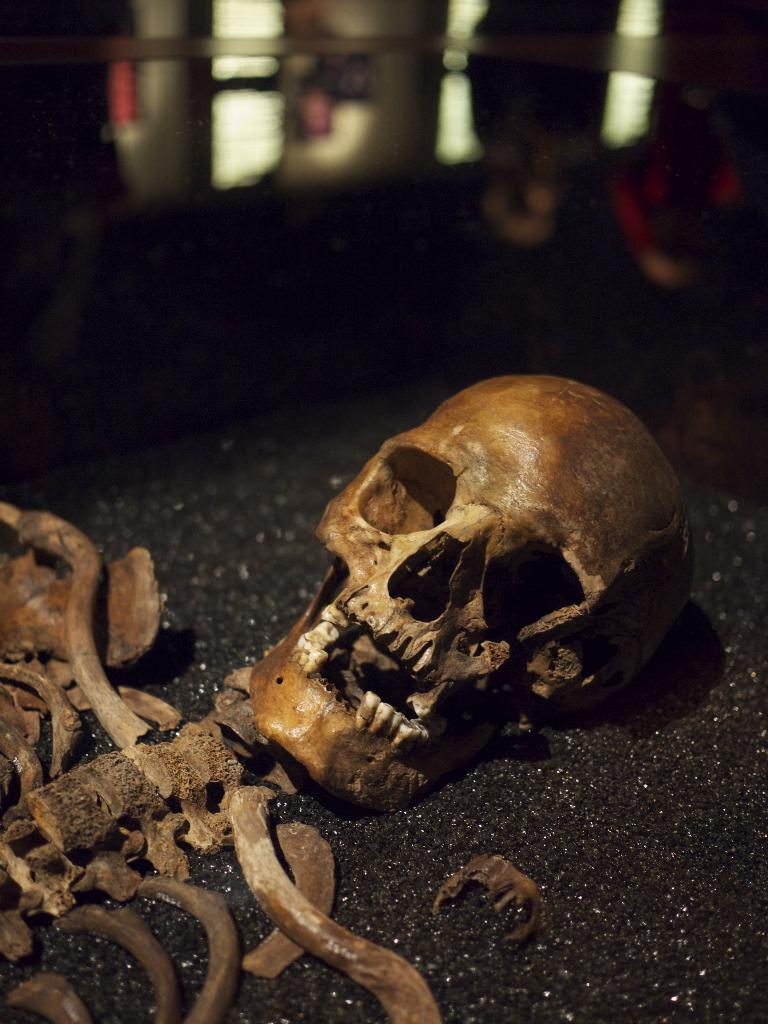What is the main subject of the image? There is a skeleton in the image. How would you describe the quality of the image? The image is blurry. Can you describe the lighting in the image? The image is in a dark setting. What type of sock is the skeleton wearing in the image? There is no sock present in the image, as the subject is a skeleton. 